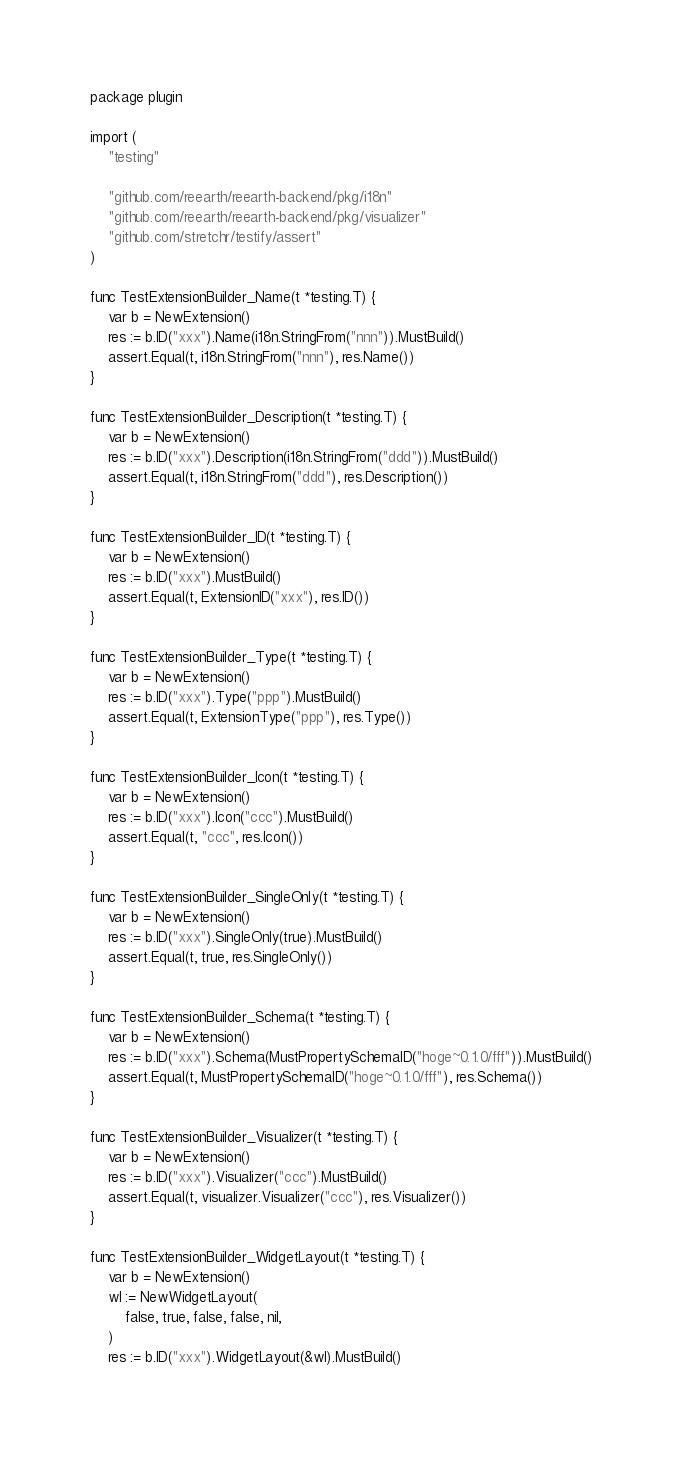<code> <loc_0><loc_0><loc_500><loc_500><_Go_>package plugin

import (
	"testing"

	"github.com/reearth/reearth-backend/pkg/i18n"
	"github.com/reearth/reearth-backend/pkg/visualizer"
	"github.com/stretchr/testify/assert"
)

func TestExtensionBuilder_Name(t *testing.T) {
	var b = NewExtension()
	res := b.ID("xxx").Name(i18n.StringFrom("nnn")).MustBuild()
	assert.Equal(t, i18n.StringFrom("nnn"), res.Name())
}

func TestExtensionBuilder_Description(t *testing.T) {
	var b = NewExtension()
	res := b.ID("xxx").Description(i18n.StringFrom("ddd")).MustBuild()
	assert.Equal(t, i18n.StringFrom("ddd"), res.Description())
}

func TestExtensionBuilder_ID(t *testing.T) {
	var b = NewExtension()
	res := b.ID("xxx").MustBuild()
	assert.Equal(t, ExtensionID("xxx"), res.ID())
}

func TestExtensionBuilder_Type(t *testing.T) {
	var b = NewExtension()
	res := b.ID("xxx").Type("ppp").MustBuild()
	assert.Equal(t, ExtensionType("ppp"), res.Type())
}

func TestExtensionBuilder_Icon(t *testing.T) {
	var b = NewExtension()
	res := b.ID("xxx").Icon("ccc").MustBuild()
	assert.Equal(t, "ccc", res.Icon())
}

func TestExtensionBuilder_SingleOnly(t *testing.T) {
	var b = NewExtension()
	res := b.ID("xxx").SingleOnly(true).MustBuild()
	assert.Equal(t, true, res.SingleOnly())
}

func TestExtensionBuilder_Schema(t *testing.T) {
	var b = NewExtension()
	res := b.ID("xxx").Schema(MustPropertySchemaID("hoge~0.1.0/fff")).MustBuild()
	assert.Equal(t, MustPropertySchemaID("hoge~0.1.0/fff"), res.Schema())
}

func TestExtensionBuilder_Visualizer(t *testing.T) {
	var b = NewExtension()
	res := b.ID("xxx").Visualizer("ccc").MustBuild()
	assert.Equal(t, visualizer.Visualizer("ccc"), res.Visualizer())
}

func TestExtensionBuilder_WidgetLayout(t *testing.T) {
	var b = NewExtension()
	wl := NewWidgetLayout(
		false, true, false, false, nil,
	)
	res := b.ID("xxx").WidgetLayout(&wl).MustBuild()</code> 